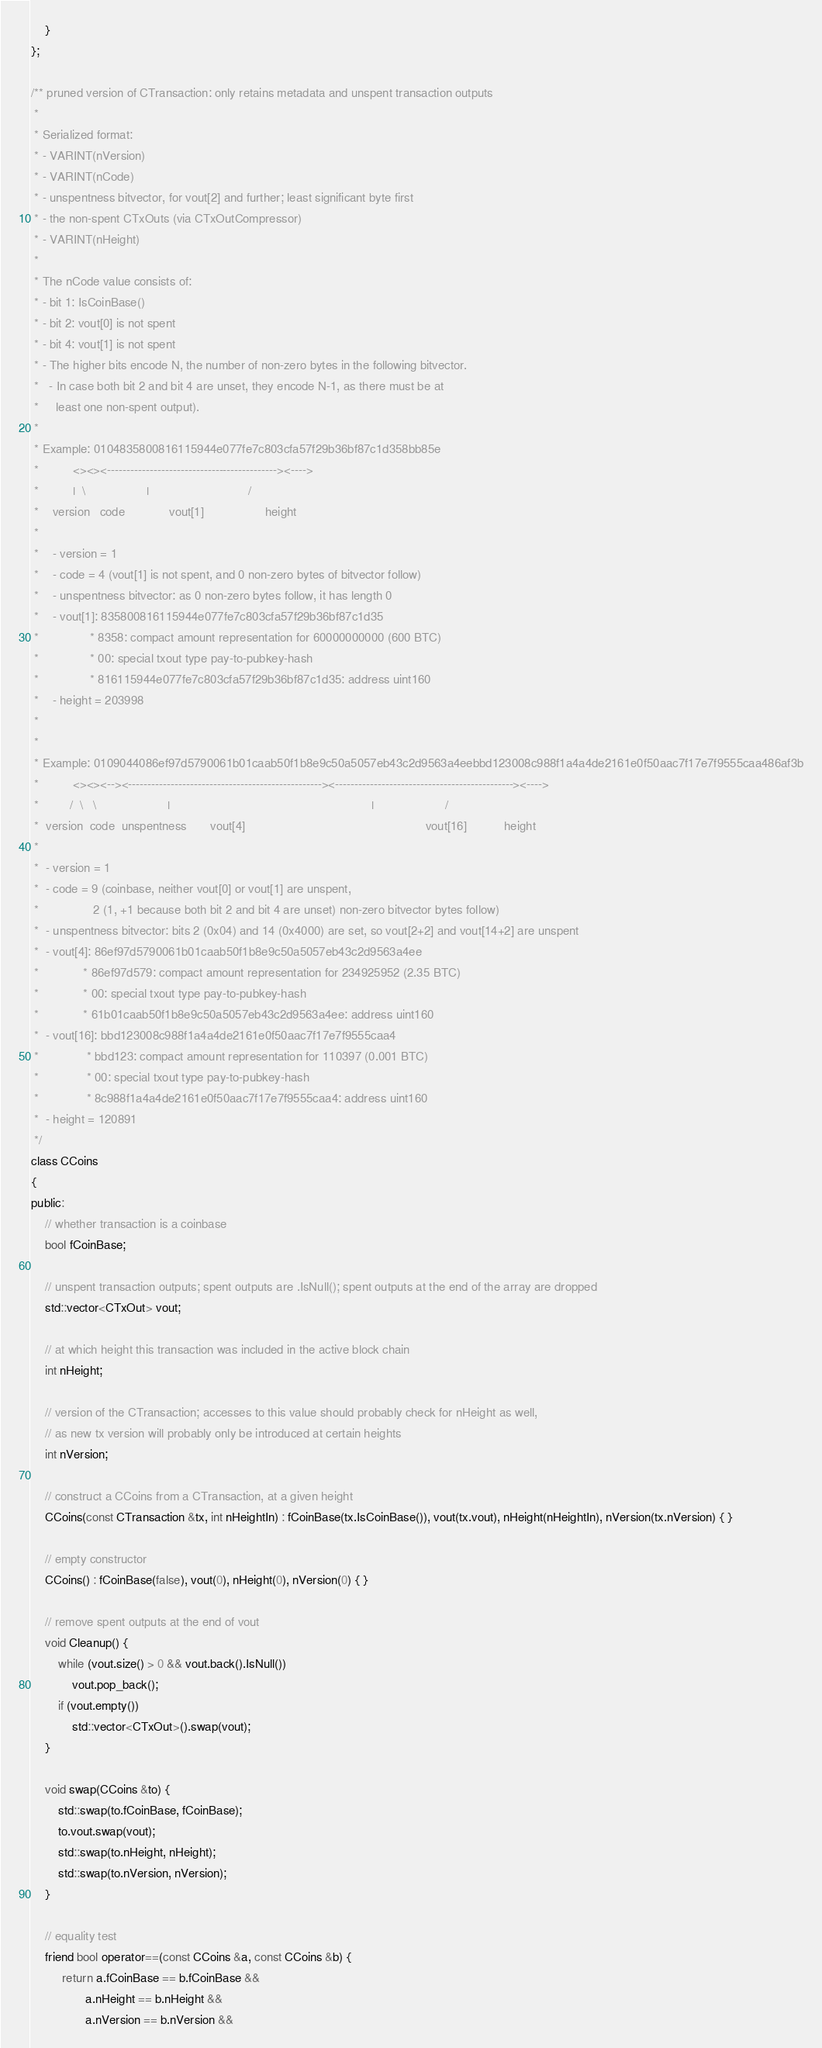<code> <loc_0><loc_0><loc_500><loc_500><_C_>    }
};

/** pruned version of CTransaction: only retains metadata and unspent transaction outputs
 *
 * Serialized format:
 * - VARINT(nVersion)
 * - VARINT(nCode)
 * - unspentness bitvector, for vout[2] and further; least significant byte first
 * - the non-spent CTxOuts (via CTxOutCompressor)
 * - VARINT(nHeight)
 *
 * The nCode value consists of:
 * - bit 1: IsCoinBase()
 * - bit 2: vout[0] is not spent
 * - bit 4: vout[1] is not spent
 * - The higher bits encode N, the number of non-zero bytes in the following bitvector.
 *   - In case both bit 2 and bit 4 are unset, they encode N-1, as there must be at
 *     least one non-spent output).
 *
 * Example: 0104835800816115944e077fe7c803cfa57f29b36bf87c1d358bb85e
 *          <><><--------------------------------------------><---->
 *          |  \                  |                             /
 *    version   code             vout[1]                  height
 *
 *    - version = 1
 *    - code = 4 (vout[1] is not spent, and 0 non-zero bytes of bitvector follow)
 *    - unspentness bitvector: as 0 non-zero bytes follow, it has length 0
 *    - vout[1]: 835800816115944e077fe7c803cfa57f29b36bf87c1d35
 *               * 8358: compact amount representation for 60000000000 (600 BTC)
 *               * 00: special txout type pay-to-pubkey-hash
 *               * 816115944e077fe7c803cfa57f29b36bf87c1d35: address uint160
 *    - height = 203998
 *
 *
 * Example: 0109044086ef97d5790061b01caab50f1b8e9c50a5057eb43c2d9563a4eebbd123008c988f1a4a4de2161e0f50aac7f17e7f9555caa486af3b
 *          <><><--><--------------------------------------------------><----------------------------------------------><---->
 *         /  \   \                     |                                                           |                     /
 *  version  code  unspentness       vout[4]                                                     vout[16]           height
 *
 *  - version = 1
 *  - code = 9 (coinbase, neither vout[0] or vout[1] are unspent,
 *                2 (1, +1 because both bit 2 and bit 4 are unset) non-zero bitvector bytes follow)
 *  - unspentness bitvector: bits 2 (0x04) and 14 (0x4000) are set, so vout[2+2] and vout[14+2] are unspent
 *  - vout[4]: 86ef97d5790061b01caab50f1b8e9c50a5057eb43c2d9563a4ee
 *             * 86ef97d579: compact amount representation for 234925952 (2.35 BTC)
 *             * 00: special txout type pay-to-pubkey-hash
 *             * 61b01caab50f1b8e9c50a5057eb43c2d9563a4ee: address uint160
 *  - vout[16]: bbd123008c988f1a4a4de2161e0f50aac7f17e7f9555caa4
 *              * bbd123: compact amount representation for 110397 (0.001 BTC)
 *              * 00: special txout type pay-to-pubkey-hash
 *              * 8c988f1a4a4de2161e0f50aac7f17e7f9555caa4: address uint160
 *  - height = 120891
 */
class CCoins
{
public:
    // whether transaction is a coinbase
    bool fCoinBase;

    // unspent transaction outputs; spent outputs are .IsNull(); spent outputs at the end of the array are dropped
    std::vector<CTxOut> vout;

    // at which height this transaction was included in the active block chain
    int nHeight;

    // version of the CTransaction; accesses to this value should probably check for nHeight as well,
    // as new tx version will probably only be introduced at certain heights
    int nVersion;

    // construct a CCoins from a CTransaction, at a given height
    CCoins(const CTransaction &tx, int nHeightIn) : fCoinBase(tx.IsCoinBase()), vout(tx.vout), nHeight(nHeightIn), nVersion(tx.nVersion) { }

    // empty constructor
    CCoins() : fCoinBase(false), vout(0), nHeight(0), nVersion(0) { }

    // remove spent outputs at the end of vout
    void Cleanup() {
        while (vout.size() > 0 && vout.back().IsNull())
            vout.pop_back();
        if (vout.empty())
            std::vector<CTxOut>().swap(vout);
    }

    void swap(CCoins &to) {
        std::swap(to.fCoinBase, fCoinBase);
        to.vout.swap(vout);
        std::swap(to.nHeight, nHeight);
        std::swap(to.nVersion, nVersion);
    }

    // equality test
    friend bool operator==(const CCoins &a, const CCoins &b) {
         return a.fCoinBase == b.fCoinBase &&
                a.nHeight == b.nHeight &&
                a.nVersion == b.nVersion &&</code> 